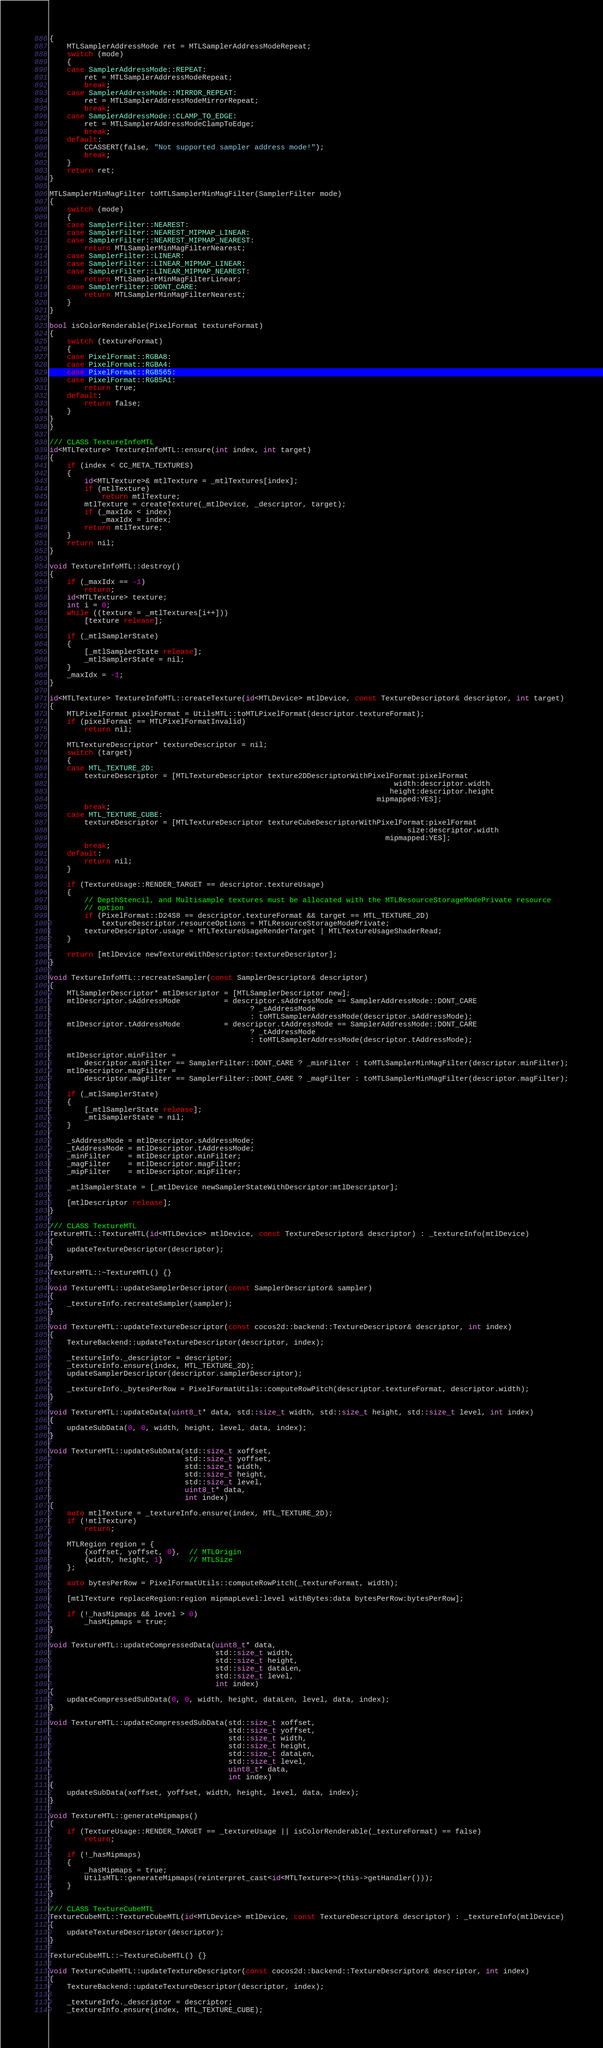<code> <loc_0><loc_0><loc_500><loc_500><_ObjectiveC_>{
    MTLSamplerAddressMode ret = MTLSamplerAddressModeRepeat;
    switch (mode)
    {
    case SamplerAddressMode::REPEAT:
        ret = MTLSamplerAddressModeRepeat;
        break;
    case SamplerAddressMode::MIRROR_REPEAT:
        ret = MTLSamplerAddressModeMirrorRepeat;
        break;
    case SamplerAddressMode::CLAMP_TO_EDGE:
        ret = MTLSamplerAddressModeClampToEdge;
        break;
    default:
        CCASSERT(false, "Not supported sampler address mode!");
        break;
    }
    return ret;
}

MTLSamplerMinMagFilter toMTLSamplerMinMagFilter(SamplerFilter mode)
{
    switch (mode)
    {
    case SamplerFilter::NEAREST:
    case SamplerFilter::NEAREST_MIPMAP_LINEAR:
    case SamplerFilter::NEAREST_MIPMAP_NEAREST:
        return MTLSamplerMinMagFilterNearest;
    case SamplerFilter::LINEAR:
    case SamplerFilter::LINEAR_MIPMAP_LINEAR:
    case SamplerFilter::LINEAR_MIPMAP_NEAREST:
        return MTLSamplerMinMagFilterLinear;
    case SamplerFilter::DONT_CARE:
        return MTLSamplerMinMagFilterNearest;
    }
}

bool isColorRenderable(PixelFormat textureFormat)
{
    switch (textureFormat)
    {
    case PixelFormat::RGBA8:
    case PixelFormat::RGBA4:
    case PixelFormat::RGB565:
    case PixelFormat::RGB5A1:
        return true;
    default:
        return false;
    }
}
}

/// CLASS TextureInfoMTL
id<MTLTexture> TextureInfoMTL::ensure(int index, int target)
{
    if (index < CC_META_TEXTURES)
    {
        id<MTLTexture>& mtlTexture = _mtlTextures[index];
        if (mtlTexture)
            return mtlTexture;
        mtlTexture = createTexture(_mtlDevice, _descriptor, target);
        if (_maxIdx < index)
            _maxIdx = index;
        return mtlTexture;
    }
    return nil;
}

void TextureInfoMTL::destroy()
{
    if (_maxIdx == -1)
        return;
    id<MTLTexture> texture;
    int i = 0;
    while ((texture = _mtlTextures[i++]))
        [texture release];

    if (_mtlSamplerState)
    {
        [_mtlSamplerState release];
        _mtlSamplerState = nil;
    }
    _maxIdx = -1;
}

id<MTLTexture> TextureInfoMTL::createTexture(id<MTLDevice> mtlDevice, const TextureDescriptor& descriptor, int target)
{
    MTLPixelFormat pixelFormat = UtilsMTL::toMTLPixelFormat(descriptor.textureFormat);
    if (pixelFormat == MTLPixelFormatInvalid)
        return nil;

    MTLTextureDescriptor* textureDescriptor = nil;
    switch (target)
    {
    case MTL_TEXTURE_2D:
        textureDescriptor = [MTLTextureDescriptor texture2DDescriptorWithPixelFormat:pixelFormat
                                                                               width:descriptor.width
                                                                              height:descriptor.height
                                                                           mipmapped:YES];
        break;
    case MTL_TEXTURE_CUBE:
        textureDescriptor = [MTLTextureDescriptor textureCubeDescriptorWithPixelFormat:pixelFormat
                                                                                  size:descriptor.width
                                                                             mipmapped:YES];
        break;
    default:
        return nil;
    }

    if (TextureUsage::RENDER_TARGET == descriptor.textureUsage)
    {
        // DepthStencil, and Multisample textures must be allocated with the MTLResourceStorageModePrivate resource
        // option
        if (PixelFormat::D24S8 == descriptor.textureFormat && target == MTL_TEXTURE_2D)
            textureDescriptor.resourceOptions = MTLResourceStorageModePrivate;
        textureDescriptor.usage = MTLTextureUsageRenderTarget | MTLTextureUsageShaderRead;
    }

    return [mtlDevice newTextureWithDescriptor:textureDescriptor];
}

void TextureInfoMTL::recreateSampler(const SamplerDescriptor& descriptor)
{
    MTLSamplerDescriptor* mtlDescriptor = [MTLSamplerDescriptor new];
    mtlDescriptor.sAddressMode          = descriptor.sAddressMode == SamplerAddressMode::DONT_CARE
                                              ? _sAddressMode
                                              : toMTLSamplerAddressMode(descriptor.sAddressMode);
    mtlDescriptor.tAddressMode          = descriptor.tAddressMode == SamplerAddressMode::DONT_CARE
                                              ? _tAddressMode
                                              : toMTLSamplerAddressMode(descriptor.tAddressMode);

    mtlDescriptor.minFilter =
        descriptor.minFilter == SamplerFilter::DONT_CARE ? _minFilter : toMTLSamplerMinMagFilter(descriptor.minFilter);
    mtlDescriptor.magFilter =
        descriptor.magFilter == SamplerFilter::DONT_CARE ? _magFilter : toMTLSamplerMinMagFilter(descriptor.magFilter);

    if (_mtlSamplerState)
    {
        [_mtlSamplerState release];
        _mtlSamplerState = nil;
    }

    _sAddressMode = mtlDescriptor.sAddressMode;
    _tAddressMode = mtlDescriptor.tAddressMode;
    _minFilter    = mtlDescriptor.minFilter;
    _magFilter    = mtlDescriptor.magFilter;
    _mipFilter    = mtlDescriptor.mipFilter;

    _mtlSamplerState = [_mtlDevice newSamplerStateWithDescriptor:mtlDescriptor];

    [mtlDescriptor release];
}

/// CLASS TextureMTL
TextureMTL::TextureMTL(id<MTLDevice> mtlDevice, const TextureDescriptor& descriptor) : _textureInfo(mtlDevice)
{
    updateTextureDescriptor(descriptor);
}

TextureMTL::~TextureMTL() {}

void TextureMTL::updateSamplerDescriptor(const SamplerDescriptor& sampler)
{
    _textureInfo.recreateSampler(sampler);
}

void TextureMTL::updateTextureDescriptor(const cocos2d::backend::TextureDescriptor& descriptor, int index)
{
    TextureBackend::updateTextureDescriptor(descriptor, index);

    _textureInfo._descriptor = descriptor;
    _textureInfo.ensure(index, MTL_TEXTURE_2D);
    updateSamplerDescriptor(descriptor.samplerDescriptor);

    _textureInfo._bytesPerRow = PixelFormatUtils::computeRowPitch(descriptor.textureFormat, descriptor.width);
}

void TextureMTL::updateData(uint8_t* data, std::size_t width, std::size_t height, std::size_t level, int index)
{
    updateSubData(0, 0, width, height, level, data, index);
}

void TextureMTL::updateSubData(std::size_t xoffset,
                               std::size_t yoffset,
                               std::size_t width,
                               std::size_t height,
                               std::size_t level,
                               uint8_t* data,
                               int index)
{
    auto mtlTexture = _textureInfo.ensure(index, MTL_TEXTURE_2D);
    if (!mtlTexture)
        return;

    MTLRegion region = {
        {xoffset, yoffset, 0},  // MTLOrigin
        {width, height, 1}      // MTLSize
    };

    auto bytesPerRow = PixelFormatUtils::computeRowPitch(_textureFormat, width);

    [mtlTexture replaceRegion:region mipmapLevel:level withBytes:data bytesPerRow:bytesPerRow];

    if (!_hasMipmaps && level > 0)
        _hasMipmaps = true;
}

void TextureMTL::updateCompressedData(uint8_t* data,
                                      std::size_t width,
                                      std::size_t height,
                                      std::size_t dataLen,
                                      std::size_t level,
                                      int index)
{
    updateCompressedSubData(0, 0, width, height, dataLen, level, data, index);
}

void TextureMTL::updateCompressedSubData(std::size_t xoffset,
                                         std::size_t yoffset,
                                         std::size_t width,
                                         std::size_t height,
                                         std::size_t dataLen,
                                         std::size_t level,
                                         uint8_t* data,
                                         int index)
{
    updateSubData(xoffset, yoffset, width, height, level, data, index);
}

void TextureMTL::generateMipmaps()
{
    if (TextureUsage::RENDER_TARGET == _textureUsage || isColorRenderable(_textureFormat) == false)
        return;

    if (!_hasMipmaps)
    {
        _hasMipmaps = true;
        UtilsMTL::generateMipmaps(reinterpret_cast<id<MTLTexture>>(this->getHandler()));
    }
}

/// CLASS TextureCubeMTL
TextureCubeMTL::TextureCubeMTL(id<MTLDevice> mtlDevice, const TextureDescriptor& descriptor) : _textureInfo(mtlDevice)
{
    updateTextureDescriptor(descriptor);
}

TextureCubeMTL::~TextureCubeMTL() {}

void TextureCubeMTL::updateTextureDescriptor(const cocos2d::backend::TextureDescriptor& descriptor, int index)
{
    TextureBackend::updateTextureDescriptor(descriptor, index);

    _textureInfo._descriptor = descriptor;
    _textureInfo.ensure(index, MTL_TEXTURE_CUBE);</code> 